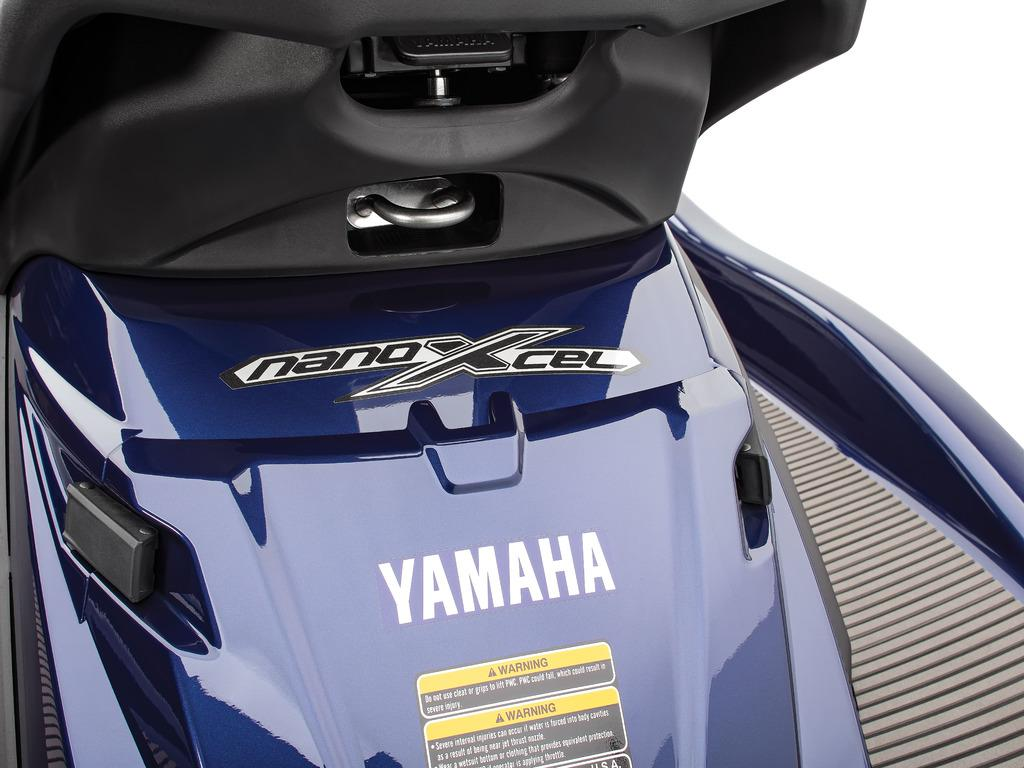What type of vehicle is in the image? There is a motor vehicle in the image. Can you see the creator of the vehicle in the image? There is no information about the creator of the vehicle in the image or the facts provided. 